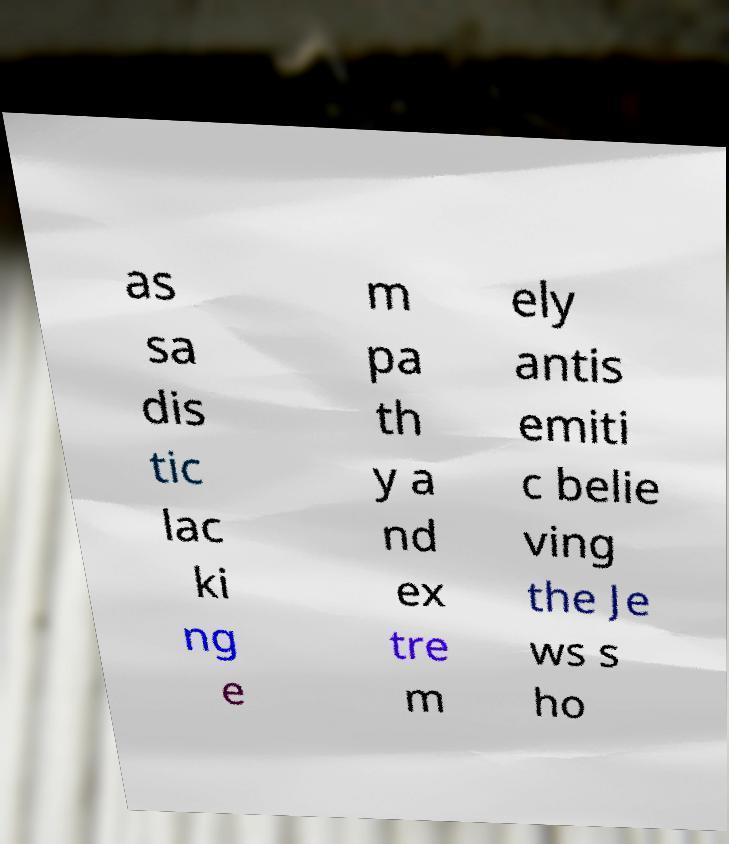Could you extract and type out the text from this image? as sa dis tic lac ki ng e m pa th y a nd ex tre m ely antis emiti c belie ving the Je ws s ho 